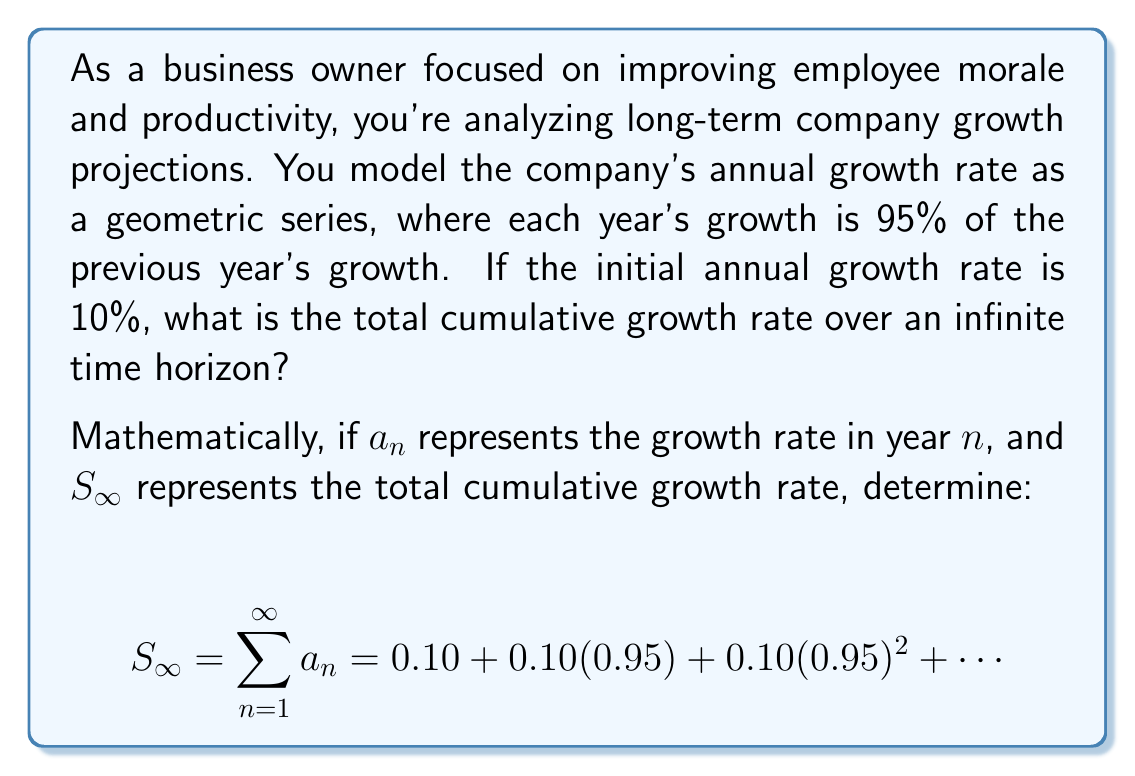Show me your answer to this math problem. To solve this problem, we'll use the formula for the sum of an infinite geometric series:

$$S_{\infty} = \frac{a}{1-r}$$

Where $a$ is the first term and $r$ is the common ratio between terms.

1) Identify the first term ($a$) and common ratio ($r$):
   $a = 0.10$ (initial growth rate)
   $r = 0.95$ (each term is 95% of the previous)

2) Check if the series converges:
   For an infinite geometric series to converge, we need $|r| < 1$
   Here, $|0.95| < 1$, so the series converges.

3) Apply the formula:
   $$S_{\infty} = \frac{0.10}{1-0.95}$$

4) Simplify:
   $$S_{\infty} = \frac{0.10}{0.05} = 2$$

This means the total cumulative growth rate over an infinite time horizon is 2, or 200%.

From a business perspective, this indicates that despite declining year-over-year growth rates, the company's total growth approaches a finite limit. This insight can be valuable for setting realistic long-term goals and managing employee expectations.
Answer: The total cumulative growth rate over an infinite time horizon is 2, or 200%. 